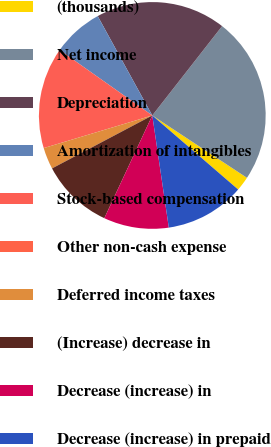<chart> <loc_0><loc_0><loc_500><loc_500><pie_chart><fcel>(thousands)<fcel>Net income<fcel>Depreciation<fcel>Amortization of intangibles<fcel>Stock-based compensation<fcel>Other non-cash expense<fcel>Deferred income taxes<fcel>(Increase) decrease in<fcel>Decrease (increase) in<fcel>Decrease (increase) in prepaid<nl><fcel>2.06%<fcel>23.71%<fcel>18.55%<fcel>7.22%<fcel>14.43%<fcel>0.0%<fcel>3.09%<fcel>10.31%<fcel>9.28%<fcel>11.34%<nl></chart> 